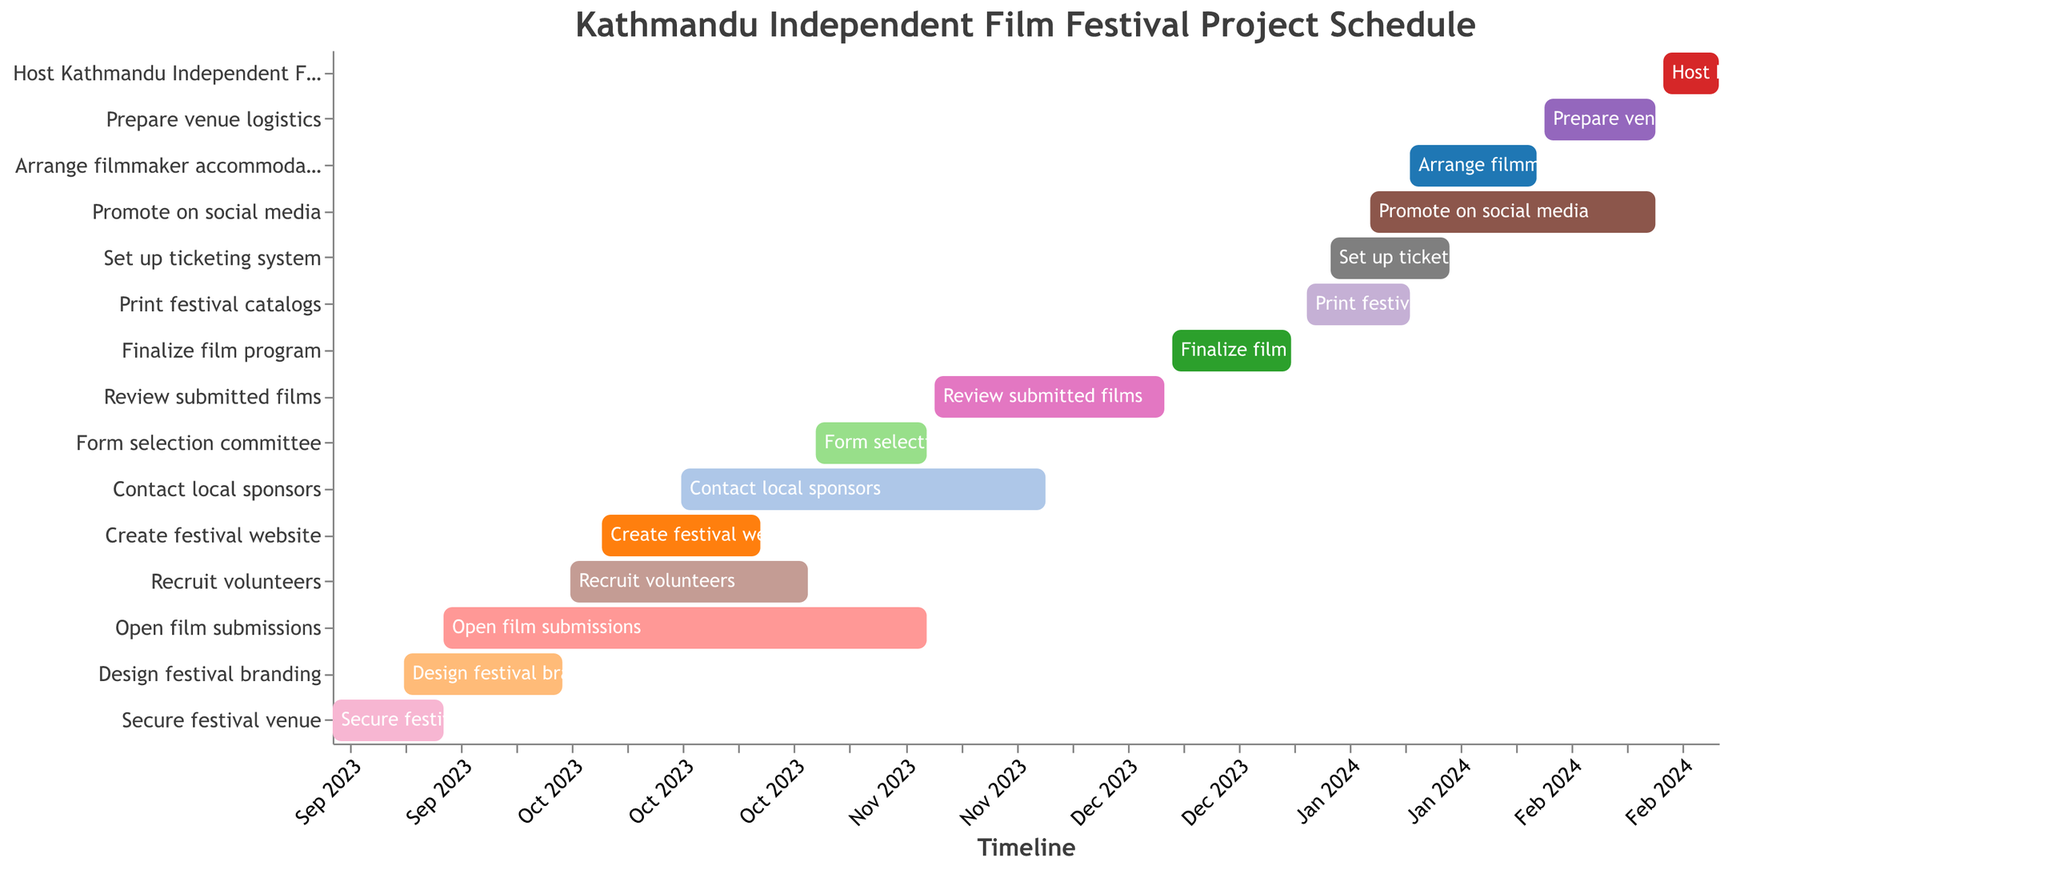What is the total duration of the 'Secure festival venue' task? The Gantt chart shows that the 'Secure festival venue' task starts on 2023-09-01 and ends on 2023-09-15. To find the duration, subtract the start date from the end date. The difference is 15 days.
Answer: 15 days When does the 'Review submitted films' task start and end? Referring to the Gantt chart, the 'Review submitted films' task starts on 2023-11-16 and ends on 2023-12-15.
Answer: 2023-11-16 to 2023-12-15 Which task has the longest duration? By comparing the durations of all tasks on the Gantt chart, it's clear that the 'Open film submissions' task has the longest duration, lasting 62 days.
Answer: Open film submissions What tasks are scheduled to start in January 2024? According to the Gantt chart, the tasks that start in January 2024 are 'Print festival catalogs' (starting on 2024-01-02), 'Set up ticketing system' (starting on 2024-01-05), 'Promote on social media' (starting on 2024-01-10), and 'Arrange filmmaker accommodations' (starting on 2024-01-15).
Answer: Print festival catalogs, Set up ticketing system, Promote on social media, Arrange filmmaker accommodations What is the overlap period between 'Create festival website' and 'Contact local sponsors' tasks? The 'Create festival website' task runs from 2023-10-05 to 2023-10-25, and the 'Contact local sponsors' task runs from 2023-10-15 to 2023-11-30. The overlap period is from 2023-10-15 to 2023-10-25.
Answer: 2023-10-15 to 2023-10-25 Arrange the tasks in November 2023 by their start dates. The tasks starting in November 2023 are 'Form selection committee' (2023-11-01) and 'Review submitted films' (2023-11-16). The order by start dates is: 1. 'Form selection committee' (2023-11-01), 2. 'Review submitted films' (2023-11-16).
Answer: Form selection committee, Review submitted films How many tasks are scheduled to start in 2024? The Gantt chart indicates four tasks starting in 2024: 'Print festival catalogs', 'Set up ticketing system', 'Promote on social media', and 'Arrange filmmaker accommodations'.
Answer: 4 tasks Which tasks have a duration shorter than 20 days? The tasks with durations shorter than 20 days are: 'Secure festival venue' (15 days), 'Form selection committee' (15 days), 'Prepare venue logistics' (15 days), 'Finalize film program' (16 days), 'Set up ticketing system' (16 days), 'Print festival catalogs' (14 days), and 'Host Kathmandu Independent Film Festival' (8 days).
Answer: Secure festival venue, Form selection committee, Prepare venue logistics, Finalize film program, Set up ticketing system, Print festival catalogs, Host Kathmandu Independent Film Festival 